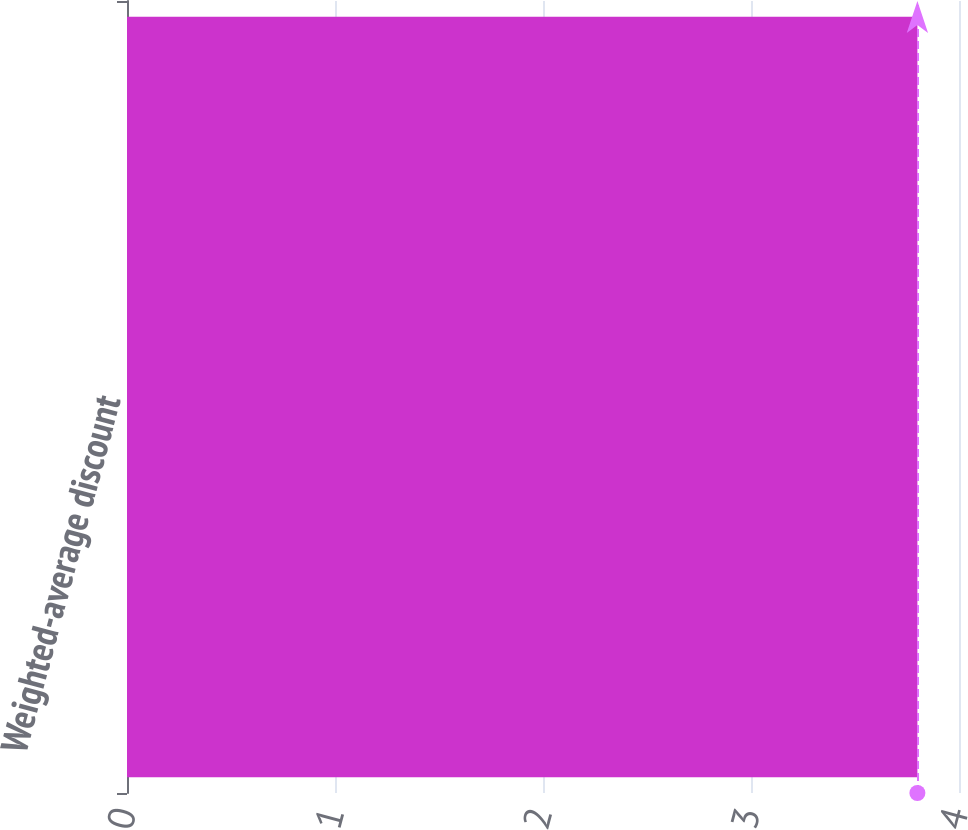Convert chart to OTSL. <chart><loc_0><loc_0><loc_500><loc_500><bar_chart><fcel>Weighted-average discount<nl><fcel>3.8<nl></chart> 